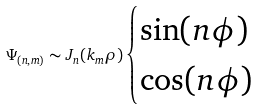<formula> <loc_0><loc_0><loc_500><loc_500>\Psi _ { ( n , m ) } \sim J _ { n } ( k _ { m } \rho ) \begin{cases} \sin ( n \phi ) \\ \cos ( n \phi ) \end{cases}</formula> 